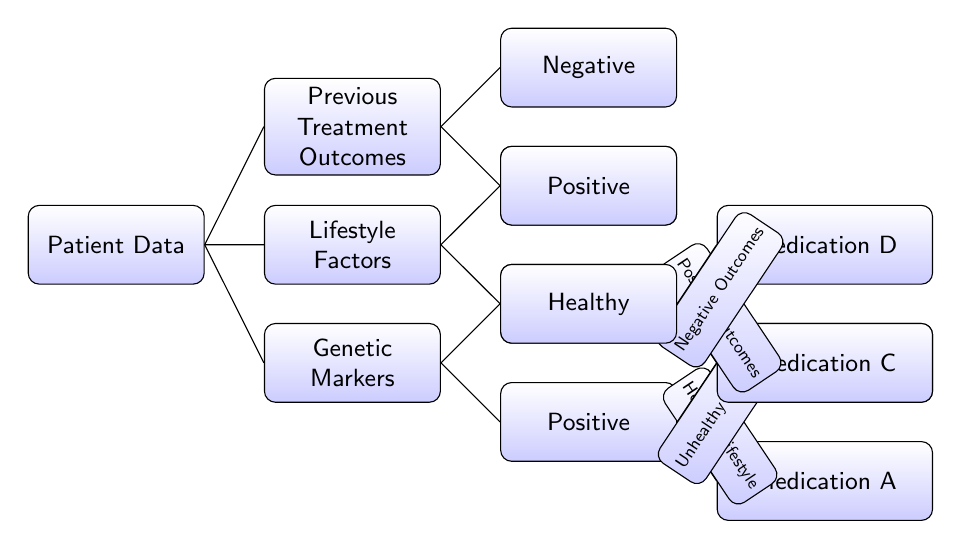What is the first decision point in the diagram? The first decision point is represented by "Patient Data," where the diagram branches out into three main factors: Genetic Markers, Lifestyle Factors, and Previous Treatment Outcomes.
Answer: Patient Data How many treatment options are classified under Positive Genetic Markers? There are two treatment options classified under Positive Genetic Markers, which are Medication A and Medication B. The diagram clearly shows that both medications are branches from the Positive marker outcome.
Answer: Two Which medication is assigned to Negative Outcomes under Negative Genetic Markers? The medication assigned is Medication D. The path leading to Medication D starts from the Negative Genetic Markers and further branches from Negative Outcomes.
Answer: Medication D What type of lifestyle factor leads to Medication A? Healthy Lifestyle leads to Medication A. This is shown by the edge connecting the Positive Genetic Markers to Medication A, indicating that it is influenced by a Healthy Lifestyle.
Answer: Healthy Lifestyle How many final treatment options are represented in the diagram? There are four final treatment options represented in the diagram. These options are Medication A, Medication B, Medication C, and Medication D, each linked to different paths based on the decision points.
Answer: Four What does a Healthy Lifestyle branch to under Lifestyle Factors? A Healthy Lifestyle does not branch to any treatment options directly in the diagram but rather serves as a part of the decision-making process leading to the treatments determined by Genetic Markers.
Answer: None Which medication is linked to Positive Outcomes from Negative Genetic Markers? Medication C is linked to Positive Outcomes from Negative Genetic Markers. It is shown as a final option following the path through Negative Genetic Markers and Positive Outcomes in the diagram.
Answer: Medication C What is the relationship between Previous Treatment Outcomes and Medication? The Previous Treatment Outcomes are classified into Positive and Negative results, leading to specific medications based on these outcomes. This relationship illustrates how past treatments dictate future decisions on medications.
Answer: Decisions on medications What color represents Medication B in the diagram? Medication B is represented in yellow color. The diagram uses color coding to visually differentiate between the medications based on associated factors and outcomes.
Answer: Yellow 